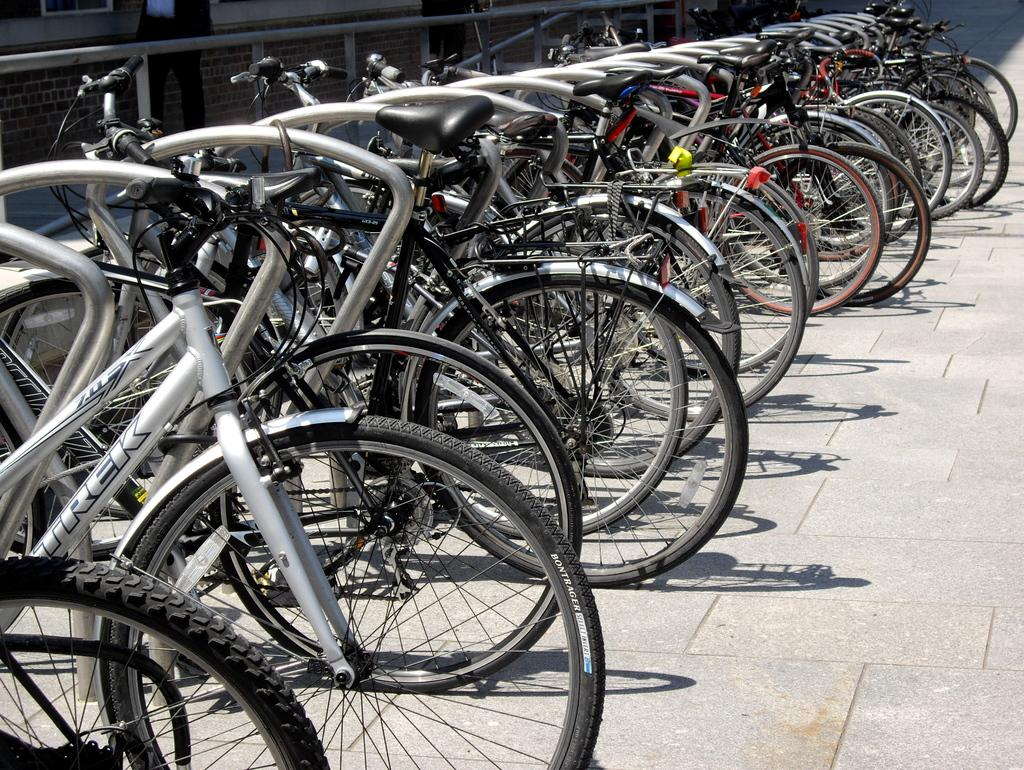What type of vehicles are in the image? There are bicycles in the image. Can you describe the people in the background of the image? There are two persons in the background of the image. What type of knife is being used to paint the toy in the image? There is no knife, paint, or toy present in the image. 